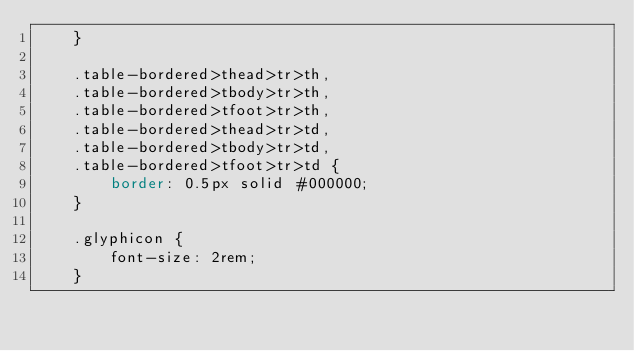<code> <loc_0><loc_0><loc_500><loc_500><_CSS_>    }
    
    .table-bordered>thead>tr>th,
    .table-bordered>tbody>tr>th,
    .table-bordered>tfoot>tr>th,
    .table-bordered>thead>tr>td,
    .table-bordered>tbody>tr>td,
    .table-bordered>tfoot>tr>td {
        border: 0.5px solid #000000;
    }
    
    .glyphicon {
        font-size: 2rem;
    }</code> 